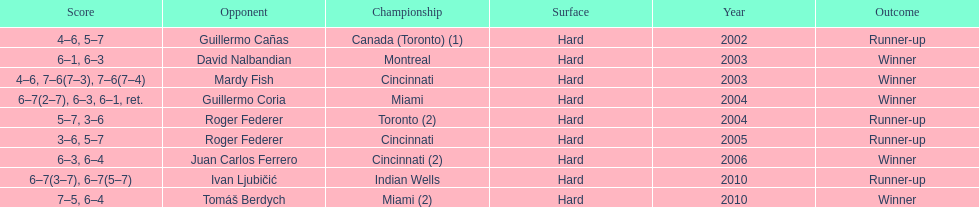How many times was roger federer a runner-up? 2. Parse the full table. {'header': ['Score', 'Opponent', 'Championship', 'Surface', 'Year', 'Outcome'], 'rows': [['4–6, 5–7', 'Guillermo Cañas', 'Canada (Toronto) (1)', 'Hard', '2002', 'Runner-up'], ['6–1, 6–3', 'David Nalbandian', 'Montreal', 'Hard', '2003', 'Winner'], ['4–6, 7–6(7–3), 7–6(7–4)', 'Mardy Fish', 'Cincinnati', 'Hard', '2003', 'Winner'], ['6–7(2–7), 6–3, 6–1, ret.', 'Guillermo Coria', 'Miami', 'Hard', '2004', 'Winner'], ['5–7, 3–6', 'Roger Federer', 'Toronto (2)', 'Hard', '2004', 'Runner-up'], ['3–6, 5–7', 'Roger Federer', 'Cincinnati', 'Hard', '2005', 'Runner-up'], ['6–3, 6–4', 'Juan Carlos Ferrero', 'Cincinnati (2)', 'Hard', '2006', 'Winner'], ['6–7(3–7), 6–7(5–7)', 'Ivan Ljubičić', 'Indian Wells', 'Hard', '2010', 'Runner-up'], ['7–5, 6–4', 'Tomáš Berdych', 'Miami (2)', 'Hard', '2010', 'Winner']]} 